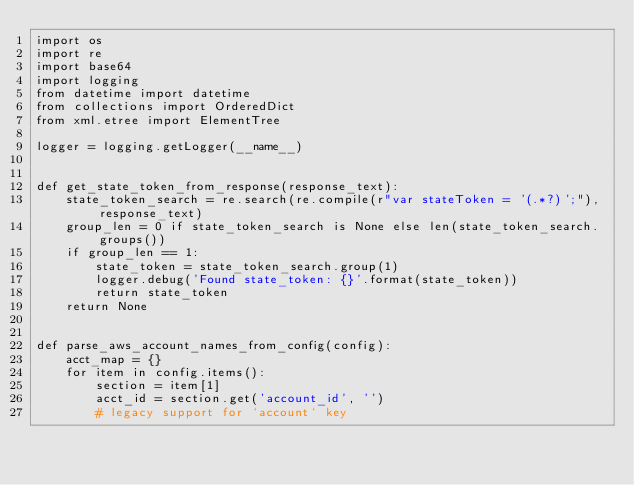Convert code to text. <code><loc_0><loc_0><loc_500><loc_500><_Python_>import os
import re
import base64
import logging
from datetime import datetime
from collections import OrderedDict
from xml.etree import ElementTree

logger = logging.getLogger(__name__)


def get_state_token_from_response(response_text):
    state_token_search = re.search(re.compile(r"var stateToken = '(.*?)';"), response_text)
    group_len = 0 if state_token_search is None else len(state_token_search.groups())
    if group_len == 1:
        state_token = state_token_search.group(1)
        logger.debug('Found state_token: {}'.format(state_token))
        return state_token
    return None


def parse_aws_account_names_from_config(config):
    acct_map = {}
    for item in config.items():
        section = item[1]
        acct_id = section.get('account_id', '')
        # legacy support for `account` key</code> 